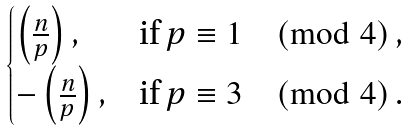Convert formula to latex. <formula><loc_0><loc_0><loc_500><loc_500>\begin{cases} \left ( \frac { n } { p } \right ) , & \text {if } p \equiv 1 \pmod { 4 } \, , \\ - \left ( \frac { n } { p } \right ) , & \text {if } p \equiv 3 \pmod { 4 } \, . \end{cases}</formula> 